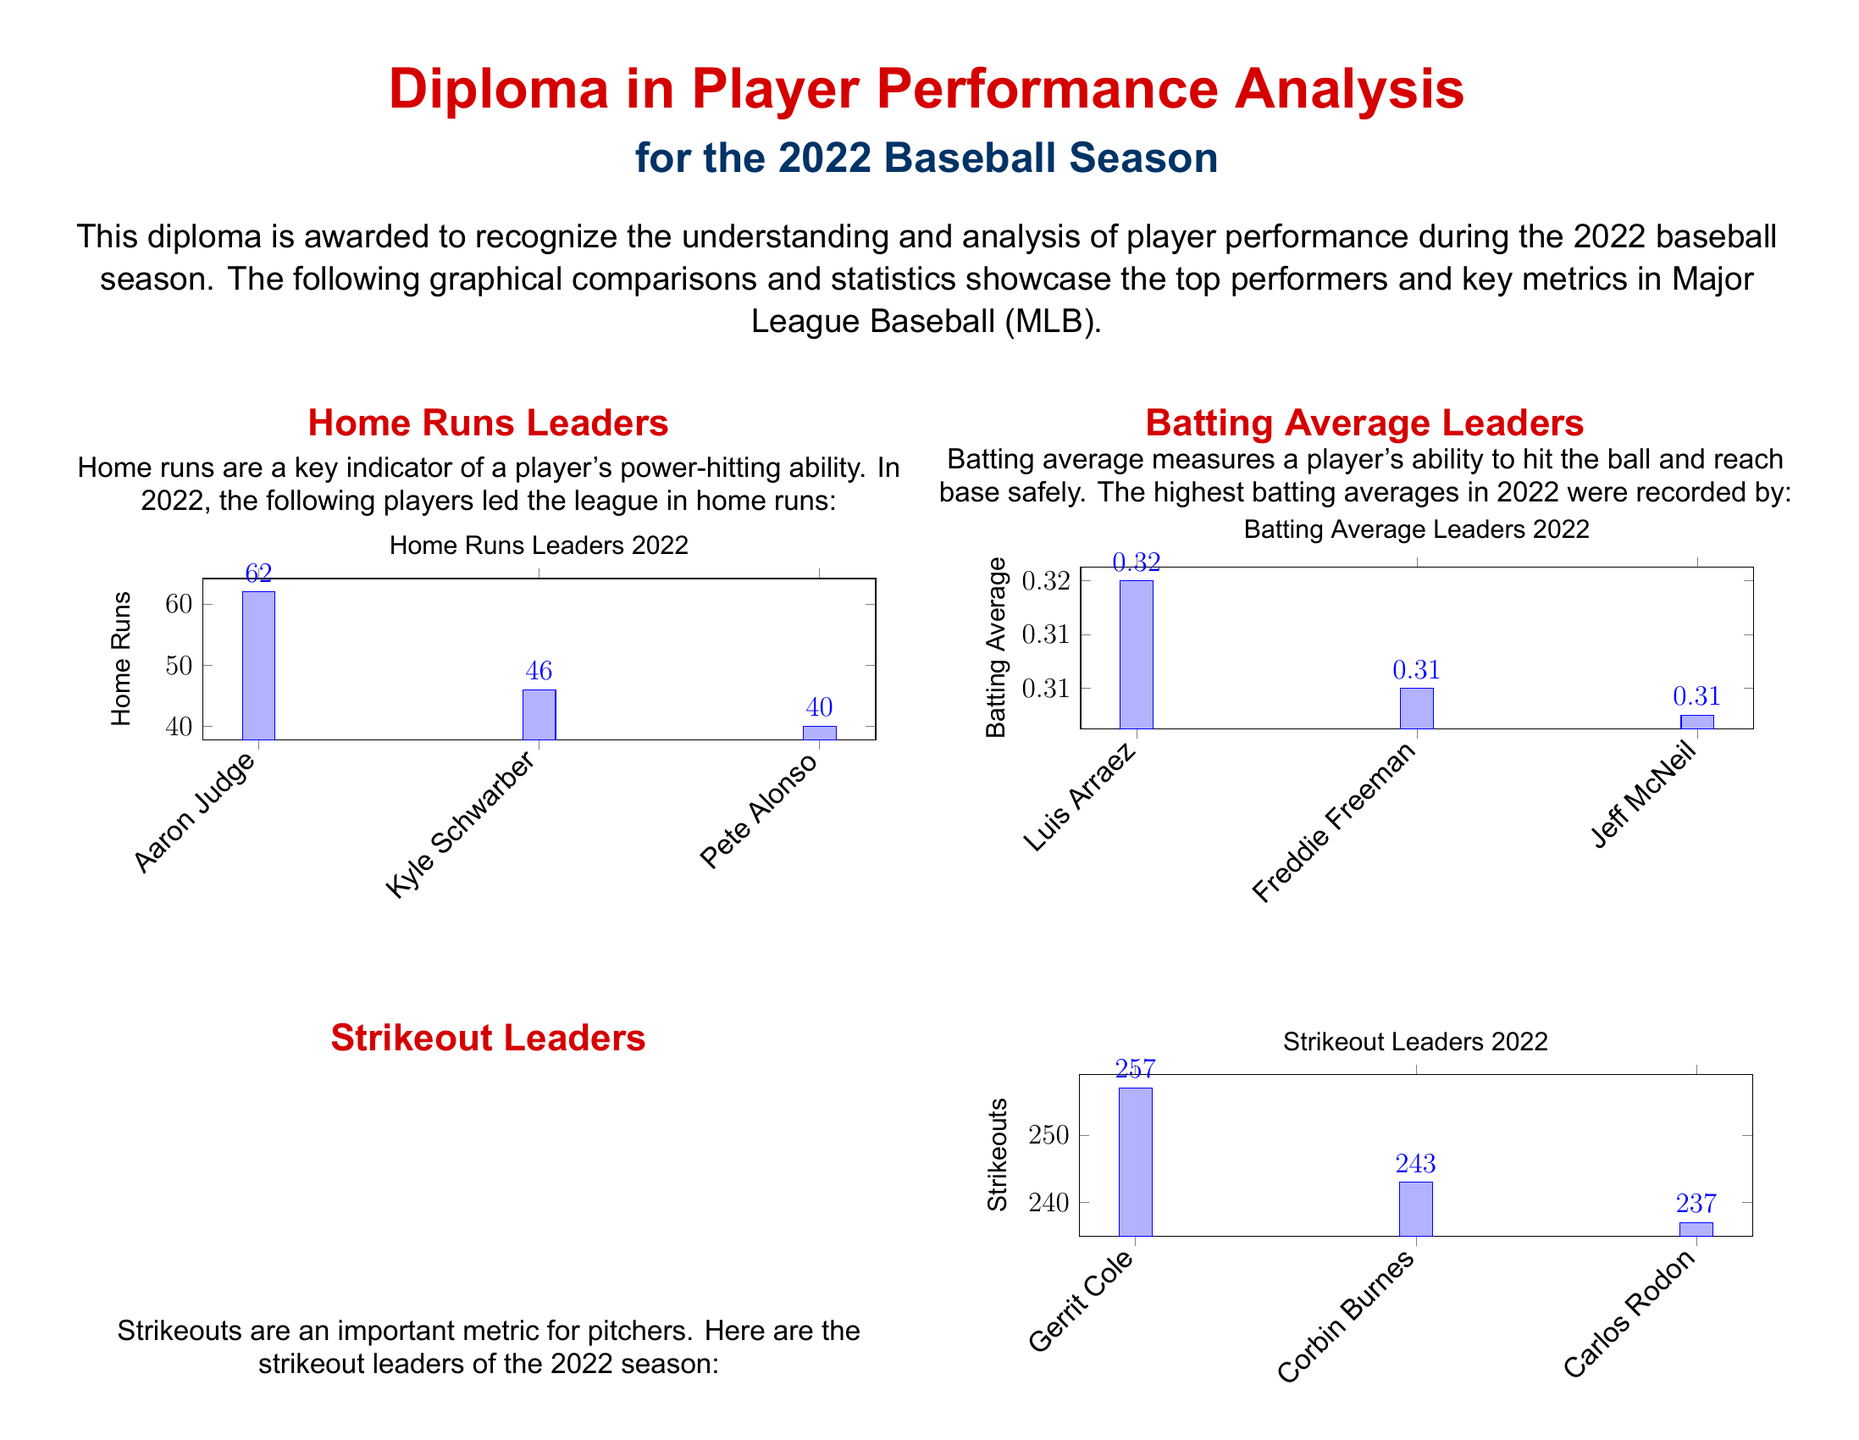What is the title of the diploma? The title of the diploma indicates the achievement it recognizes, which is "Diploma in Player Performance Analysis."
Answer: Diploma in Player Performance Analysis Who led the league in home runs in 2022? The player with the highest number of home runs is listed, which is "Aaron Judge."
Answer: Aaron Judge What was Aaron Judge's home run count? The count of home runs hit by Aaron Judge is provided in the document, which is 62.
Answer: 62 Which player had the highest batting average in 2022? The player with the highest batting average recorded is stated, which is "Luis Arraez."
Answer: Luis Arraez What is the batting average of Freddie Freeman? The batting average for Freddie Freeman is specifically mentioned in the document, which is 0.312.
Answer: 0.312 Who was the strikeout leader in 2022? The player with the most strikeouts is listed in the document as "Gerrit Cole."
Answer: Gerrit Cole How many strikeouts did Carlos Rodon have? The document states Carlos Rodon's total strikeouts, which is 237.
Answer: 237 What is the maximum number of stolen bases recorded by the top player? The highest number of stolen bases by any player mentioned is for Jon Berti, which is 41.
Answer: 41 What season does this diploma refer to? The diploma specifies the baseball season it covers, which is the 2022 season.
Answer: 2022 